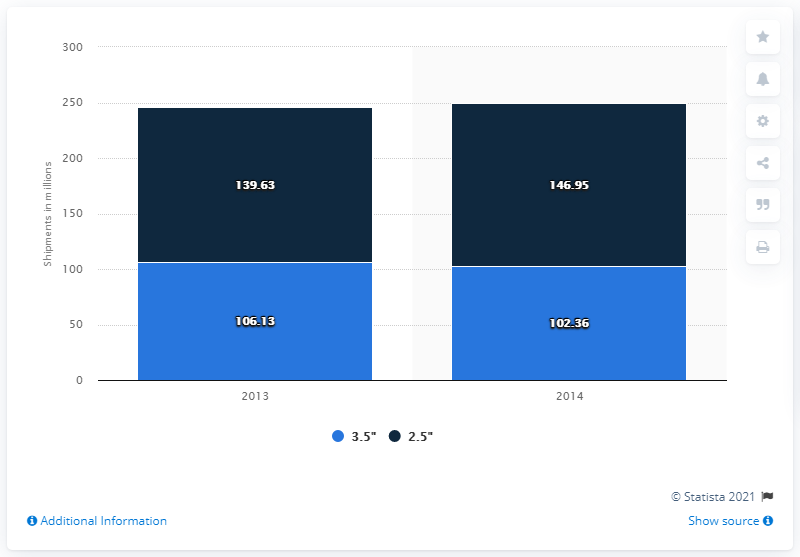Which year has the highest value? The year 2014 has the highest total value when combining both categories depicted in the bar chart, with 146.95 million units in the 3.5" size, and 102.36 million units in the 2.5" size, summing to a total of 249.31 million units shipped. 